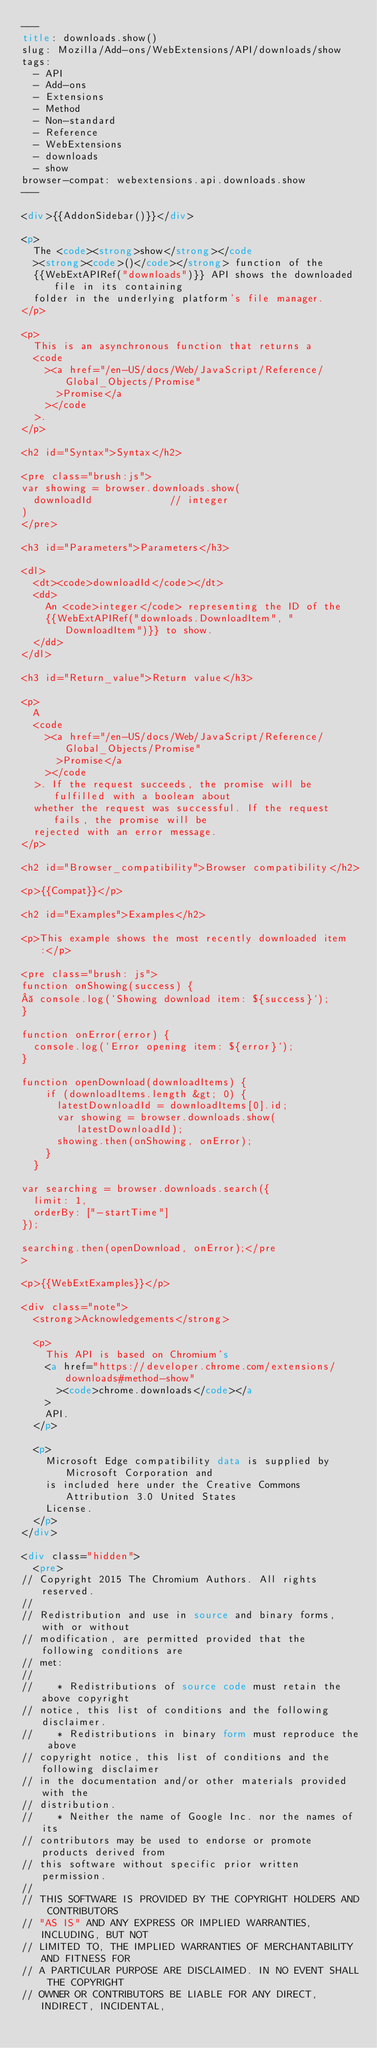Convert code to text. <code><loc_0><loc_0><loc_500><loc_500><_HTML_>---
title: downloads.show()
slug: Mozilla/Add-ons/WebExtensions/API/downloads/show
tags:
  - API
  - Add-ons
  - Extensions
  - Method
  - Non-standard
  - Reference
  - WebExtensions
  - downloads
  - show
browser-compat: webextensions.api.downloads.show
---

<div>{{AddonSidebar()}}</div>

<p>
  The <code><strong>show</strong></code
  ><strong><code>()</code></strong> function of the
  {{WebExtAPIRef("downloads")}} API shows the downloaded file in its containing
  folder in the underlying platform's file manager.
</p>

<p>
  This is an asynchronous function that returns a
  <code
    ><a href="/en-US/docs/Web/JavaScript/Reference/Global_Objects/Promise"
      >Promise</a
    ></code
  >.
</p>

<h2 id="Syntax">Syntax</h2>

<pre class="brush:js">
var showing = browser.downloads.show(
  downloadId             // integer
)
</pre>

<h3 id="Parameters">Parameters</h3>

<dl>
  <dt><code>downloadId</code></dt>
  <dd>
    An <code>integer</code> representing the ID of the
    {{WebExtAPIRef("downloads.DownloadItem", "DownloadItem")}} to show.
  </dd>
</dl>

<h3 id="Return_value">Return value</h3>

<p>
  A
  <code
    ><a href="/en-US/docs/Web/JavaScript/Reference/Global_Objects/Promise"
      >Promise</a
    ></code
  >. If the request succeeds, the promise will be fulfilled with a boolean about
  whether the request was successful. If the request fails, the promise will be
  rejected with an error message.
</p>

<h2 id="Browser_compatibility">Browser compatibility</h2>

<p>{{Compat}}</p>

<h2 id="Examples">Examples</h2>

<p>This example shows the most recently downloaded item:</p>

<pre class="brush: js">
function onShowing(success) {
  console.log(`Showing download item: ${success}`);
}

function onError(error) {
  console.log(`Error opening item: ${error}`);
}

function openDownload(downloadItems) {
    if (downloadItems.length &gt; 0) {
      latestDownloadId = downloadItems[0].id;
      var showing = browser.downloads.show(latestDownloadId);
      showing.then(onShowing, onError);
    }
  }

var searching = browser.downloads.search({
  limit: 1,
  orderBy: ["-startTime"]
});

searching.then(openDownload, onError);</pre
>

<p>{{WebExtExamples}}</p>

<div class="note">
  <strong>Acknowledgements</strong>

  <p>
    This API is based on Chromium's
    <a href="https://developer.chrome.com/extensions/downloads#method-show"
      ><code>chrome.downloads</code></a
    >
    API.
  </p>

  <p>
    Microsoft Edge compatibility data is supplied by Microsoft Corporation and
    is included here under the Creative Commons Attribution 3.0 United States
    License.
  </p>
</div>

<div class="hidden">
  <pre>
// Copyright 2015 The Chromium Authors. All rights reserved.
//
// Redistribution and use in source and binary forms, with or without
// modification, are permitted provided that the following conditions are
// met:
//
//    * Redistributions of source code must retain the above copyright
// notice, this list of conditions and the following disclaimer.
//    * Redistributions in binary form must reproduce the above
// copyright notice, this list of conditions and the following disclaimer
// in the documentation and/or other materials provided with the
// distribution.
//    * Neither the name of Google Inc. nor the names of its
// contributors may be used to endorse or promote products derived from
// this software without specific prior written permission.
//
// THIS SOFTWARE IS PROVIDED BY THE COPYRIGHT HOLDERS AND CONTRIBUTORS
// "AS IS" AND ANY EXPRESS OR IMPLIED WARRANTIES, INCLUDING, BUT NOT
// LIMITED TO, THE IMPLIED WARRANTIES OF MERCHANTABILITY AND FITNESS FOR
// A PARTICULAR PURPOSE ARE DISCLAIMED. IN NO EVENT SHALL THE COPYRIGHT
// OWNER OR CONTRIBUTORS BE LIABLE FOR ANY DIRECT, INDIRECT, INCIDENTAL,</code> 